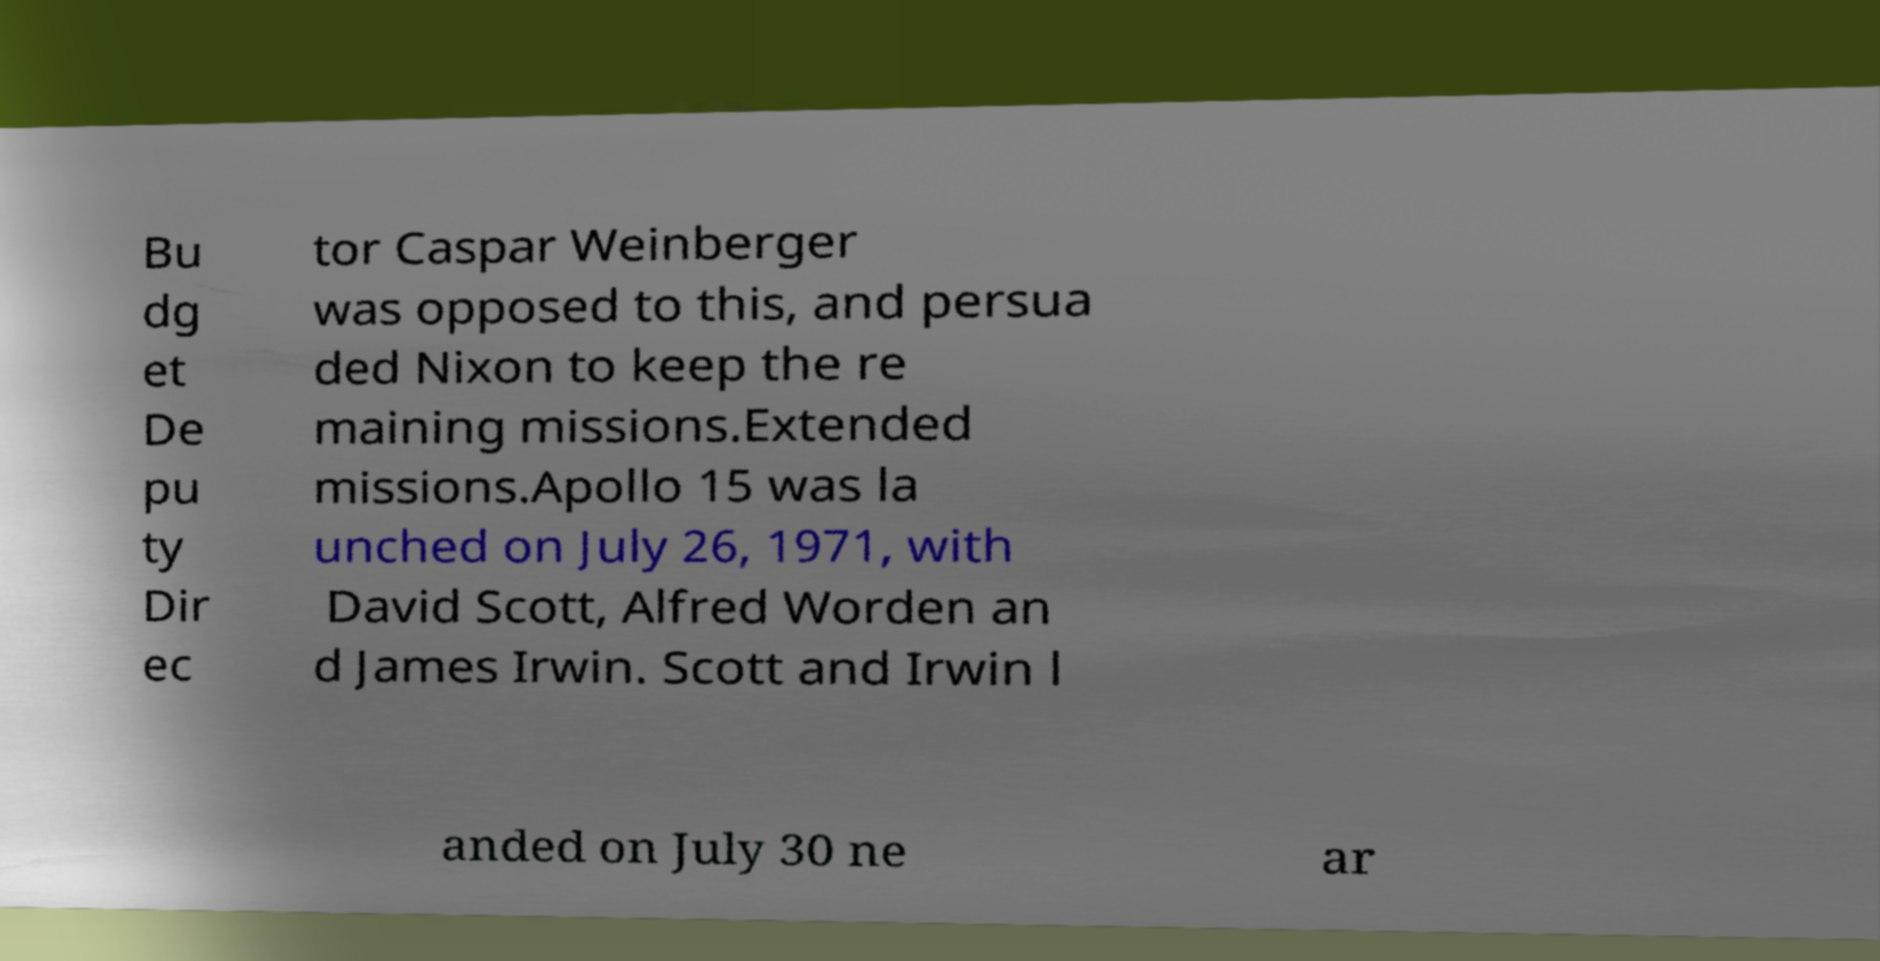Could you assist in decoding the text presented in this image and type it out clearly? Bu dg et De pu ty Dir ec tor Caspar Weinberger was opposed to this, and persua ded Nixon to keep the re maining missions.Extended missions.Apollo 15 was la unched on July 26, 1971, with David Scott, Alfred Worden an d James Irwin. Scott and Irwin l anded on July 30 ne ar 